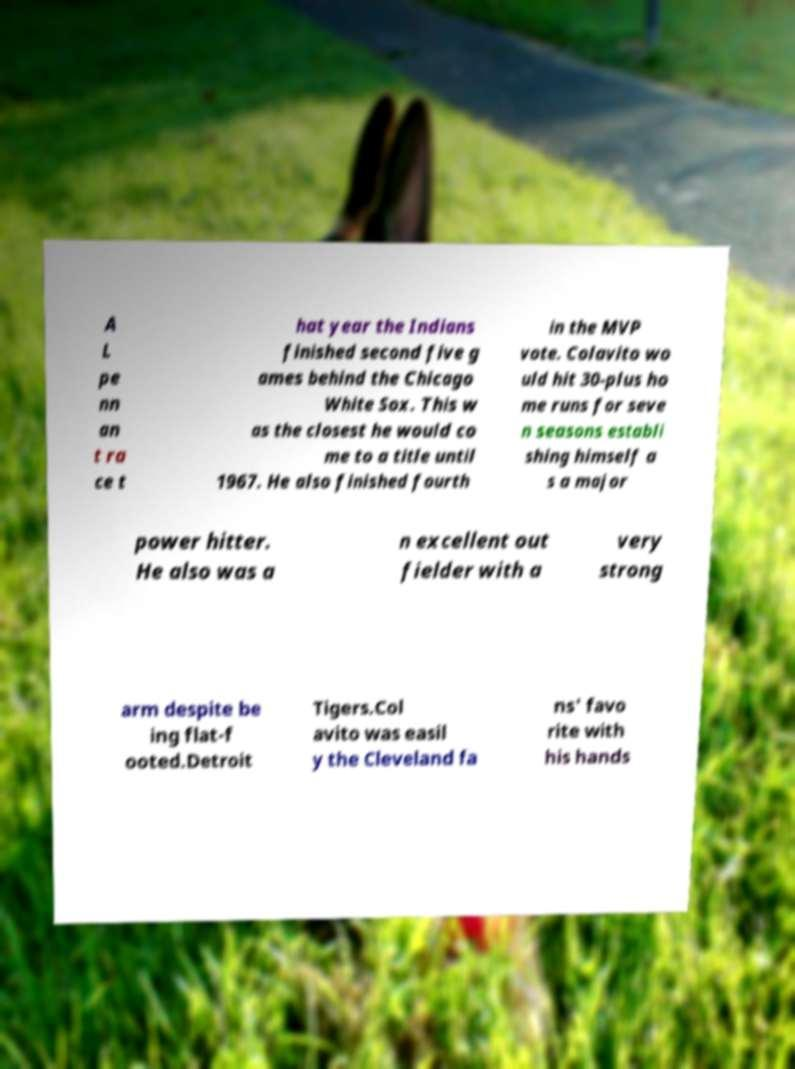What messages or text are displayed in this image? I need them in a readable, typed format. A L pe nn an t ra ce t hat year the Indians finished second five g ames behind the Chicago White Sox. This w as the closest he would co me to a title until 1967. He also finished fourth in the MVP vote. Colavito wo uld hit 30-plus ho me runs for seve n seasons establi shing himself a s a major power hitter. He also was a n excellent out fielder with a very strong arm despite be ing flat-f ooted.Detroit Tigers.Col avito was easil y the Cleveland fa ns' favo rite with his hands 